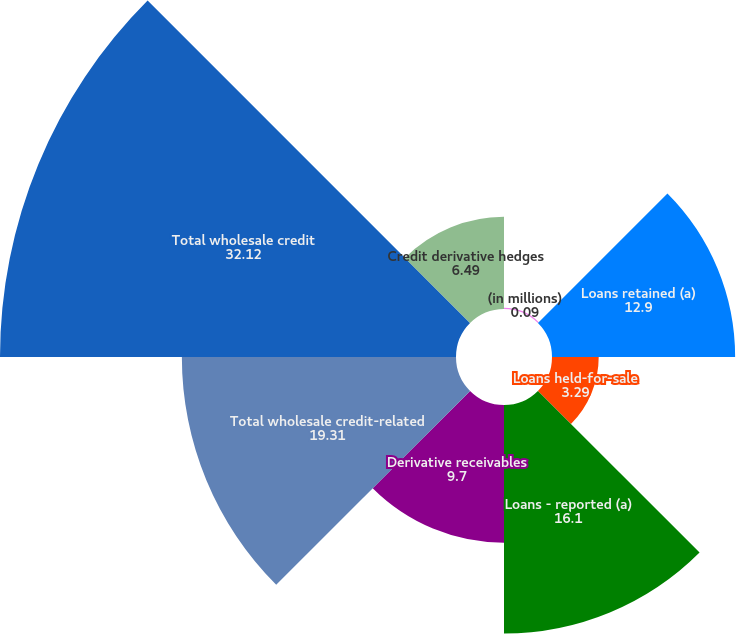Convert chart to OTSL. <chart><loc_0><loc_0><loc_500><loc_500><pie_chart><fcel>(in millions)<fcel>Loans retained (a)<fcel>Loans held-for-sale<fcel>Loans - reported (a)<fcel>Derivative receivables<fcel>Total wholesale credit-related<fcel>Total wholesale credit<fcel>Credit derivative hedges<nl><fcel>0.09%<fcel>12.9%<fcel>3.29%<fcel>16.1%<fcel>9.7%<fcel>19.31%<fcel>32.12%<fcel>6.49%<nl></chart> 